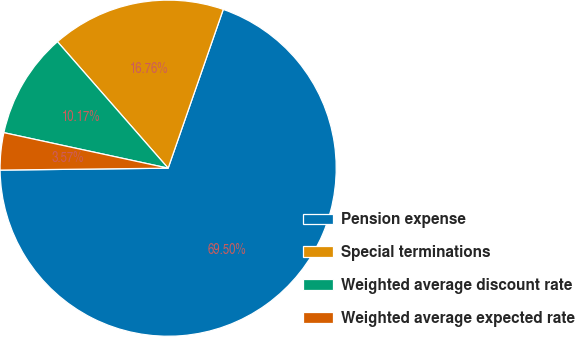Convert chart. <chart><loc_0><loc_0><loc_500><loc_500><pie_chart><fcel>Pension expense<fcel>Special terminations<fcel>Weighted average discount rate<fcel>Weighted average expected rate<nl><fcel>69.5%<fcel>16.76%<fcel>10.17%<fcel>3.57%<nl></chart> 